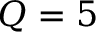<formula> <loc_0><loc_0><loc_500><loc_500>Q = 5</formula> 